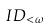<formula> <loc_0><loc_0><loc_500><loc_500>I D _ { < \omega }</formula> 